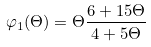<formula> <loc_0><loc_0><loc_500><loc_500>\varphi _ { 1 } ( \Theta ) = \Theta \frac { 6 + 1 5 \Theta } { 4 + 5 \Theta }</formula> 